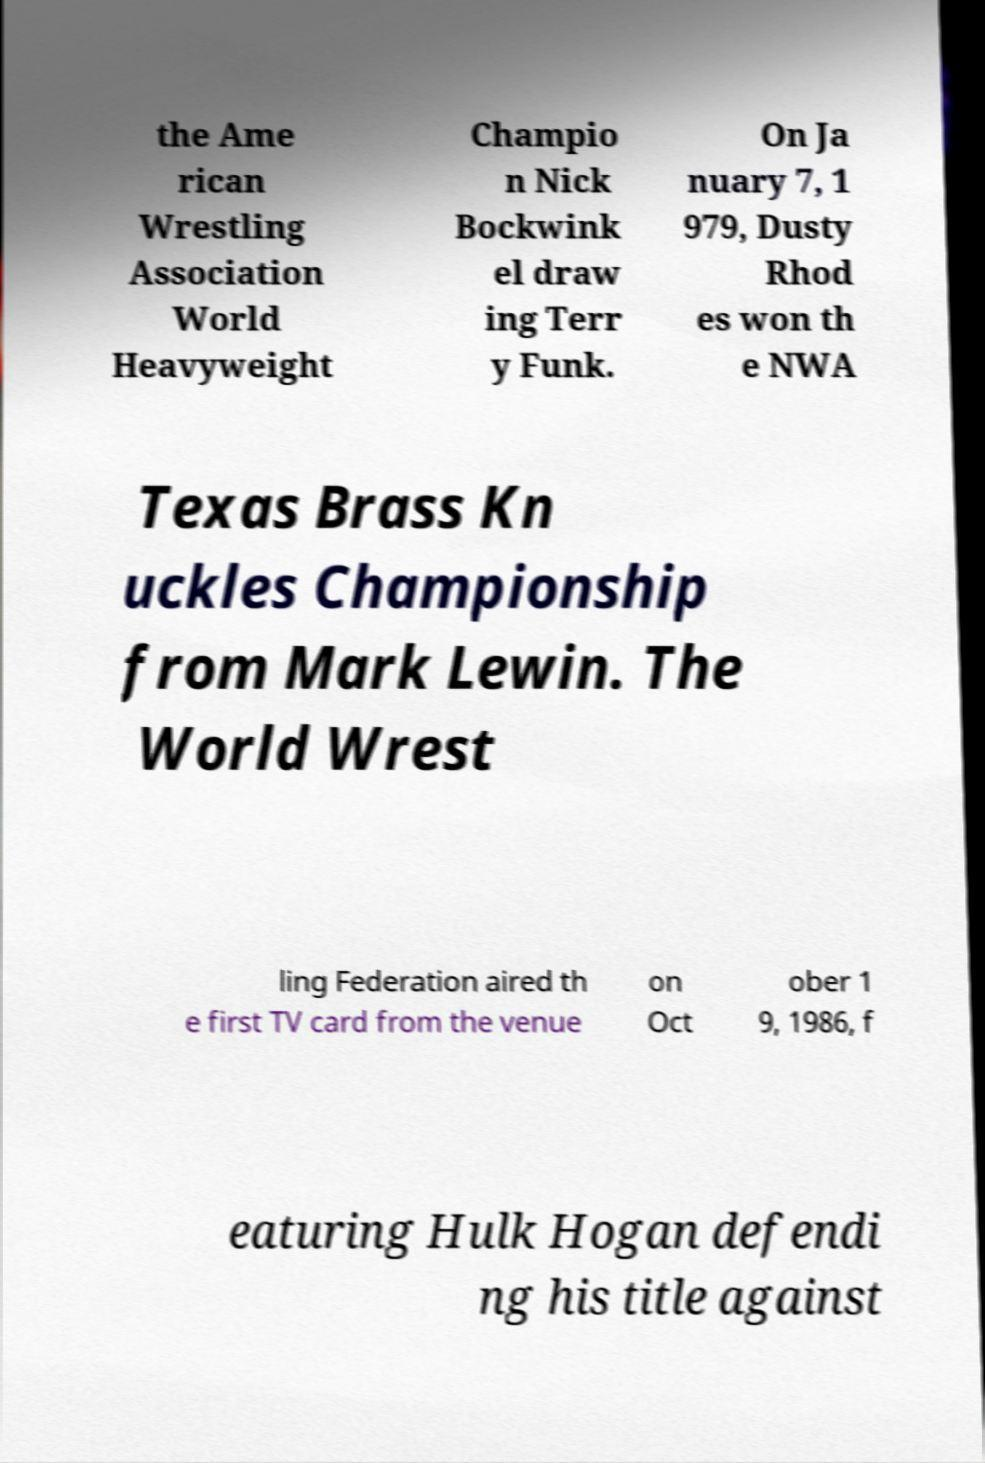I need the written content from this picture converted into text. Can you do that? the Ame rican Wrestling Association World Heavyweight Champio n Nick Bockwink el draw ing Terr y Funk. On Ja nuary 7, 1 979, Dusty Rhod es won th e NWA Texas Brass Kn uckles Championship from Mark Lewin. The World Wrest ling Federation aired th e first TV card from the venue on Oct ober 1 9, 1986, f eaturing Hulk Hogan defendi ng his title against 